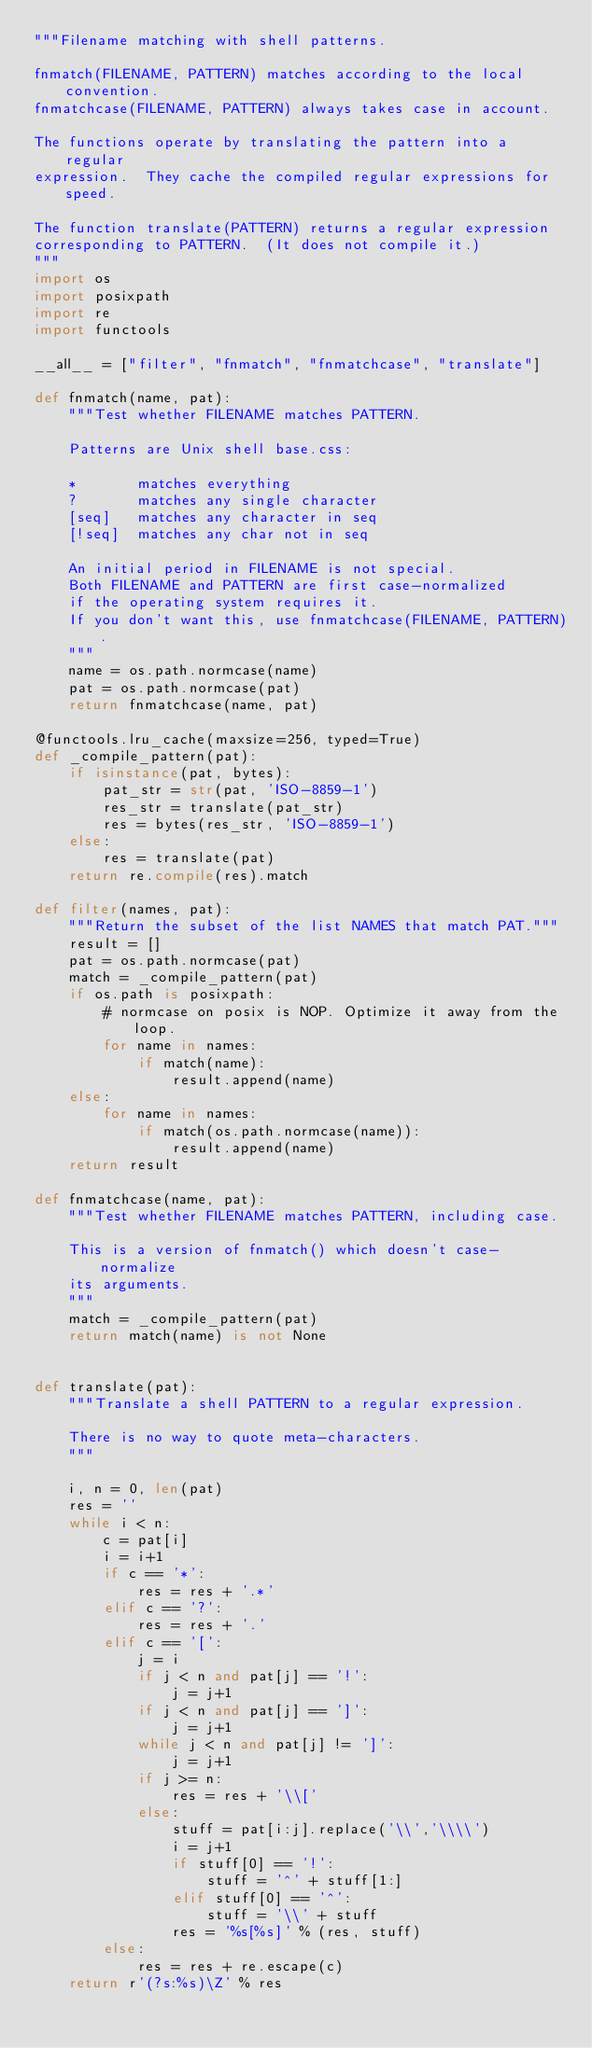<code> <loc_0><loc_0><loc_500><loc_500><_Python_>"""Filename matching with shell patterns.

fnmatch(FILENAME, PATTERN) matches according to the local convention.
fnmatchcase(FILENAME, PATTERN) always takes case in account.

The functions operate by translating the pattern into a regular
expression.  They cache the compiled regular expressions for speed.

The function translate(PATTERN) returns a regular expression
corresponding to PATTERN.  (It does not compile it.)
"""
import os
import posixpath
import re
import functools

__all__ = ["filter", "fnmatch", "fnmatchcase", "translate"]

def fnmatch(name, pat):
    """Test whether FILENAME matches PATTERN.

    Patterns are Unix shell base.css:

    *       matches everything
    ?       matches any single character
    [seq]   matches any character in seq
    [!seq]  matches any char not in seq

    An initial period in FILENAME is not special.
    Both FILENAME and PATTERN are first case-normalized
    if the operating system requires it.
    If you don't want this, use fnmatchcase(FILENAME, PATTERN).
    """
    name = os.path.normcase(name)
    pat = os.path.normcase(pat)
    return fnmatchcase(name, pat)

@functools.lru_cache(maxsize=256, typed=True)
def _compile_pattern(pat):
    if isinstance(pat, bytes):
        pat_str = str(pat, 'ISO-8859-1')
        res_str = translate(pat_str)
        res = bytes(res_str, 'ISO-8859-1')
    else:
        res = translate(pat)
    return re.compile(res).match

def filter(names, pat):
    """Return the subset of the list NAMES that match PAT."""
    result = []
    pat = os.path.normcase(pat)
    match = _compile_pattern(pat)
    if os.path is posixpath:
        # normcase on posix is NOP. Optimize it away from the loop.
        for name in names:
            if match(name):
                result.append(name)
    else:
        for name in names:
            if match(os.path.normcase(name)):
                result.append(name)
    return result

def fnmatchcase(name, pat):
    """Test whether FILENAME matches PATTERN, including case.

    This is a version of fnmatch() which doesn't case-normalize
    its arguments.
    """
    match = _compile_pattern(pat)
    return match(name) is not None


def translate(pat):
    """Translate a shell PATTERN to a regular expression.

    There is no way to quote meta-characters.
    """

    i, n = 0, len(pat)
    res = ''
    while i < n:
        c = pat[i]
        i = i+1
        if c == '*':
            res = res + '.*'
        elif c == '?':
            res = res + '.'
        elif c == '[':
            j = i
            if j < n and pat[j] == '!':
                j = j+1
            if j < n and pat[j] == ']':
                j = j+1
            while j < n and pat[j] != ']':
                j = j+1
            if j >= n:
                res = res + '\\['
            else:
                stuff = pat[i:j].replace('\\','\\\\')
                i = j+1
                if stuff[0] == '!':
                    stuff = '^' + stuff[1:]
                elif stuff[0] == '^':
                    stuff = '\\' + stuff
                res = '%s[%s]' % (res, stuff)
        else:
            res = res + re.escape(c)
    return r'(?s:%s)\Z' % res
</code> 